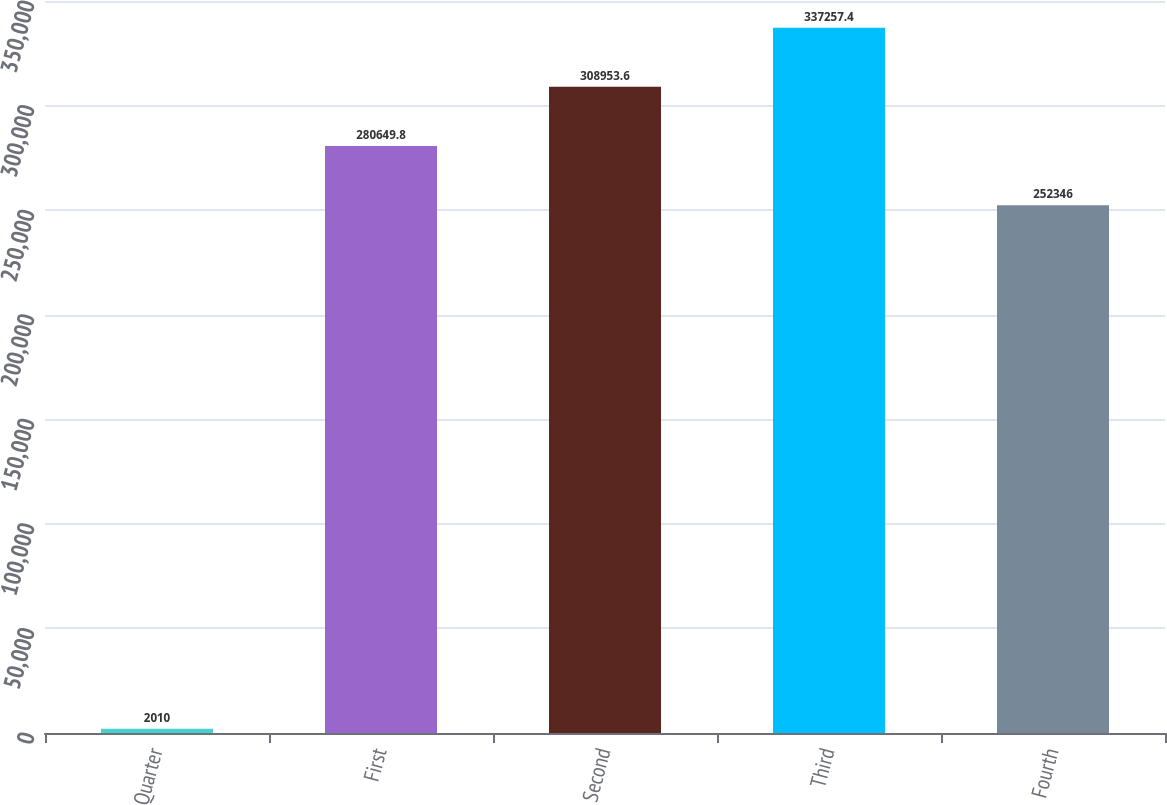Convert chart. <chart><loc_0><loc_0><loc_500><loc_500><bar_chart><fcel>Quarter<fcel>First<fcel>Second<fcel>Third<fcel>Fourth<nl><fcel>2010<fcel>280650<fcel>308954<fcel>337257<fcel>252346<nl></chart> 